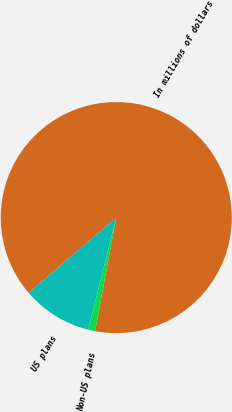Convert chart. <chart><loc_0><loc_0><loc_500><loc_500><pie_chart><fcel>In millions of dollars<fcel>US plans<fcel>Non-US plans<nl><fcel>89.23%<fcel>9.8%<fcel>0.97%<nl></chart> 